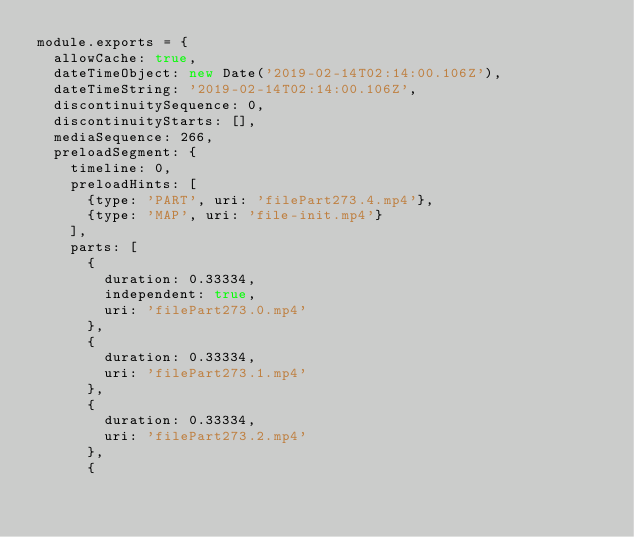<code> <loc_0><loc_0><loc_500><loc_500><_JavaScript_>module.exports = {
  allowCache: true,
  dateTimeObject: new Date('2019-02-14T02:14:00.106Z'),
  dateTimeString: '2019-02-14T02:14:00.106Z',
  discontinuitySequence: 0,
  discontinuityStarts: [],
  mediaSequence: 266,
  preloadSegment: {
    timeline: 0,
    preloadHints: [
      {type: 'PART', uri: 'filePart273.4.mp4'},
      {type: 'MAP', uri: 'file-init.mp4'}
    ],
    parts: [
      {
        duration: 0.33334,
        independent: true,
        uri: 'filePart273.0.mp4'
      },
      {
        duration: 0.33334,
        uri: 'filePart273.1.mp4'
      },
      {
        duration: 0.33334,
        uri: 'filePart273.2.mp4'
      },
      {</code> 